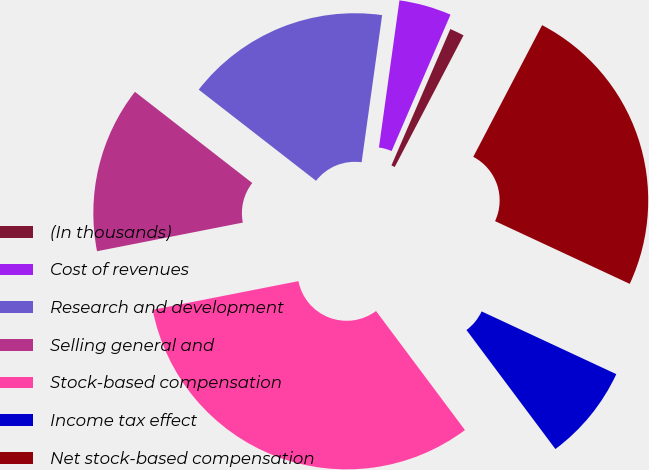<chart> <loc_0><loc_0><loc_500><loc_500><pie_chart><fcel>(In thousands)<fcel>Cost of revenues<fcel>Research and development<fcel>Selling general and<fcel>Stock-based compensation<fcel>Income tax effect<fcel>Net stock-based compensation<nl><fcel>1.18%<fcel>4.28%<fcel>16.69%<fcel>13.6%<fcel>32.12%<fcel>7.85%<fcel>24.27%<nl></chart> 